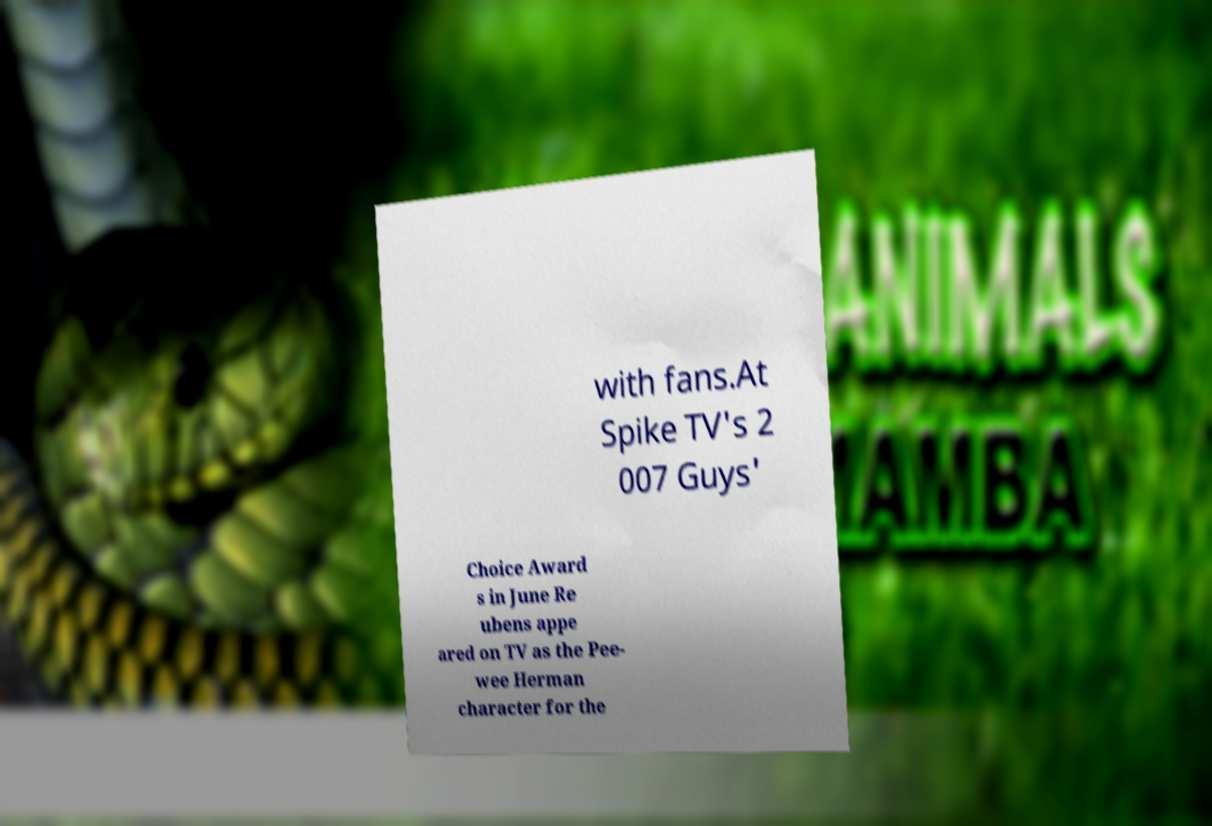I need the written content from this picture converted into text. Can you do that? with fans.At Spike TV's 2 007 Guys' Choice Award s in June Re ubens appe ared on TV as the Pee- wee Herman character for the 